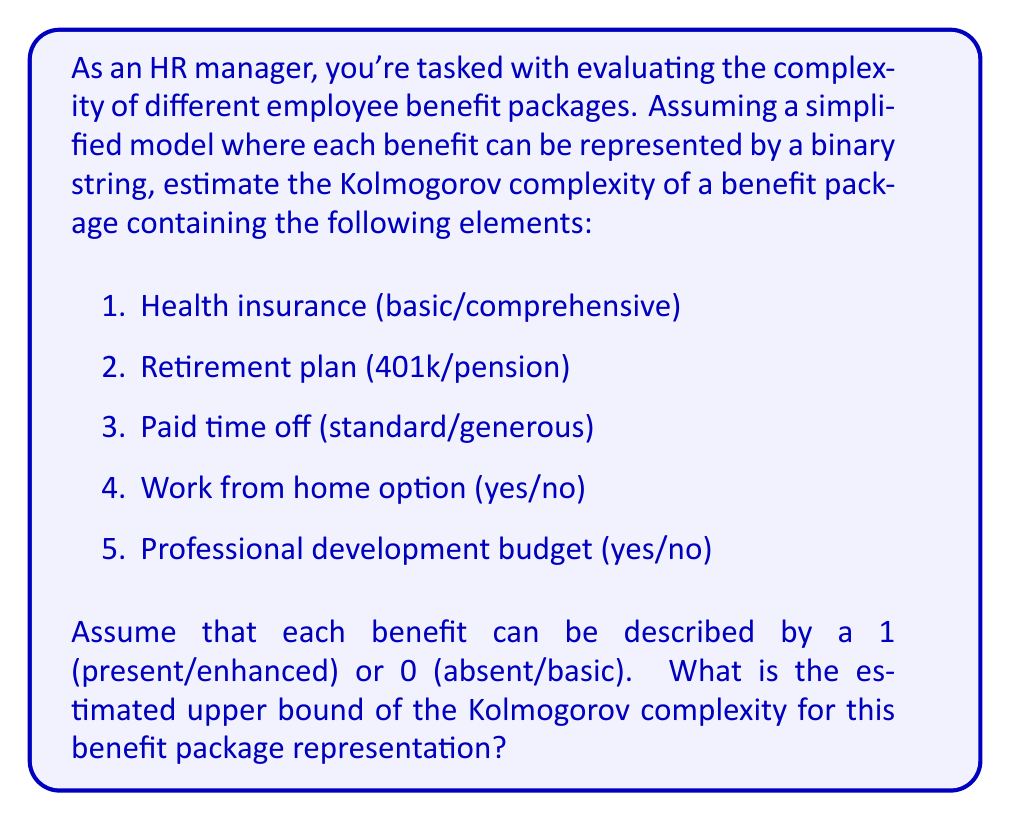Solve this math problem. To estimate the Kolmogorov complexity of the employee benefit package, we need to consider the following:

1. Kolmogorov complexity is the length of the shortest program that can produce the given string.

2. In this case, we're representing each benefit as a binary choice, which means we have 5 bits of information.

3. The upper bound of Kolmogorov complexity for a string is generally considered to be the length of the string itself, plus some small constant for the program overhead.

4. In information theory, we often use logarithms to measure information content. The information content of a string of length $n$ is typically bounded by $O(\log n)$ bits.

5. For our benefit package, we have $2^5 = 32$ possible combinations.

6. The logarithm (base 2) of 32 is 5, which matches our intuition that we need 5 bits to represent all possibilities.

7. To account for program overhead, we add a small constant $c$. This constant represents the instructions needed to interpret and output the 5-bit string.

Therefore, an upper bound for the Kolmogorov complexity $K(x)$ of our benefit package $x$ can be estimated as:

$$ K(x) \leq 5 + c $$

Where $c$ is a small constant, typically in the range of 1-10 bits depending on the specific encoding method used.
Answer: The estimated upper bound of the Kolmogorov complexity for this benefit package representation is $5 + c$ bits, where $c$ is a small constant representing program overhead. 